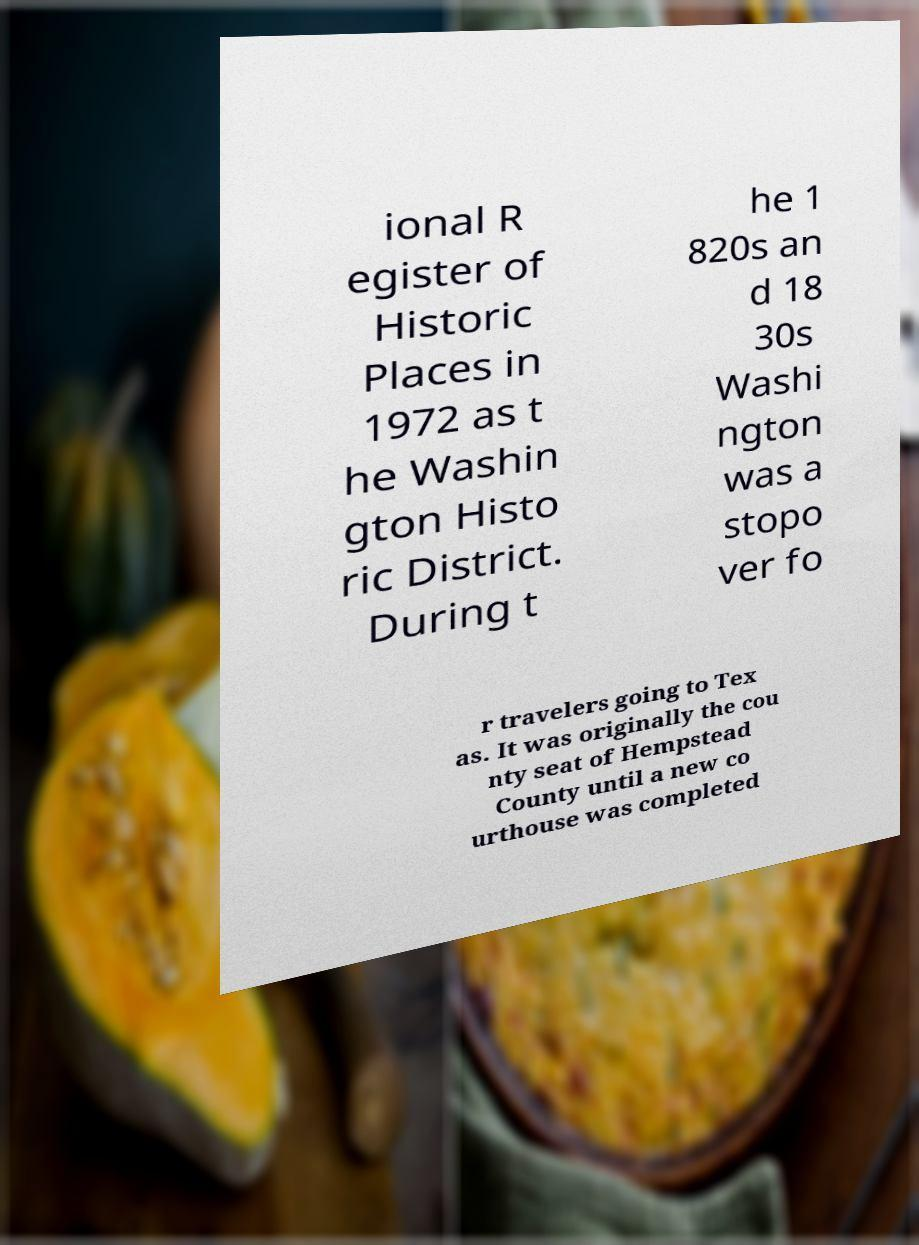Please read and relay the text visible in this image. What does it say? ional R egister of Historic Places in 1972 as t he Washin gton Histo ric District. During t he 1 820s an d 18 30s Washi ngton was a stopo ver fo r travelers going to Tex as. It was originally the cou nty seat of Hempstead County until a new co urthouse was completed 